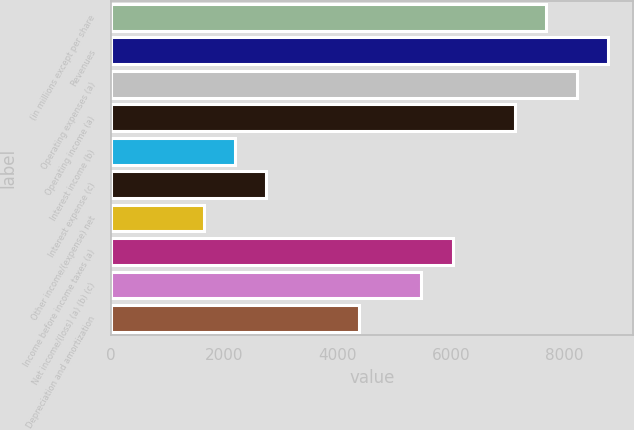<chart> <loc_0><loc_0><loc_500><loc_500><bar_chart><fcel>(in millions except per share<fcel>Revenues<fcel>Operating expenses (a)<fcel>Operating income (a)<fcel>Interest income (b)<fcel>Interest expense (c)<fcel>Other income/(expense) net<fcel>Income before income taxes (a)<fcel>Net income/(loss) (a) (b) (c)<fcel>Depreciation and amortization<nl><fcel>7676.96<fcel>8773.58<fcel>8225.27<fcel>7128.65<fcel>2193.86<fcel>2742.17<fcel>1645.55<fcel>6032.03<fcel>5483.72<fcel>4387.1<nl></chart> 